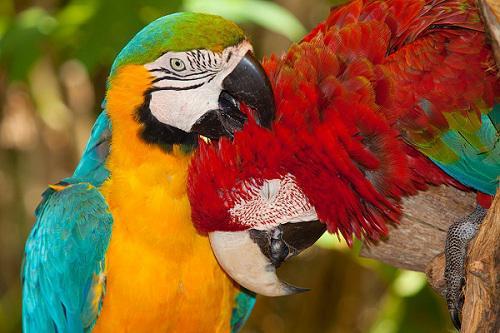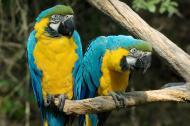The first image is the image on the left, the second image is the image on the right. Analyze the images presented: Is the assertion "One image includes a red-feathered parrot along with a blue-and-yellow parrot." valid? Answer yes or no. Yes. The first image is the image on the left, the second image is the image on the right. For the images displayed, is the sentence "Exactly four parrots are shown, two in each image, all of them with the same eye design and gold chests, one pair looking at each other, while one pair looks in the same direction." factually correct? Answer yes or no. No. 